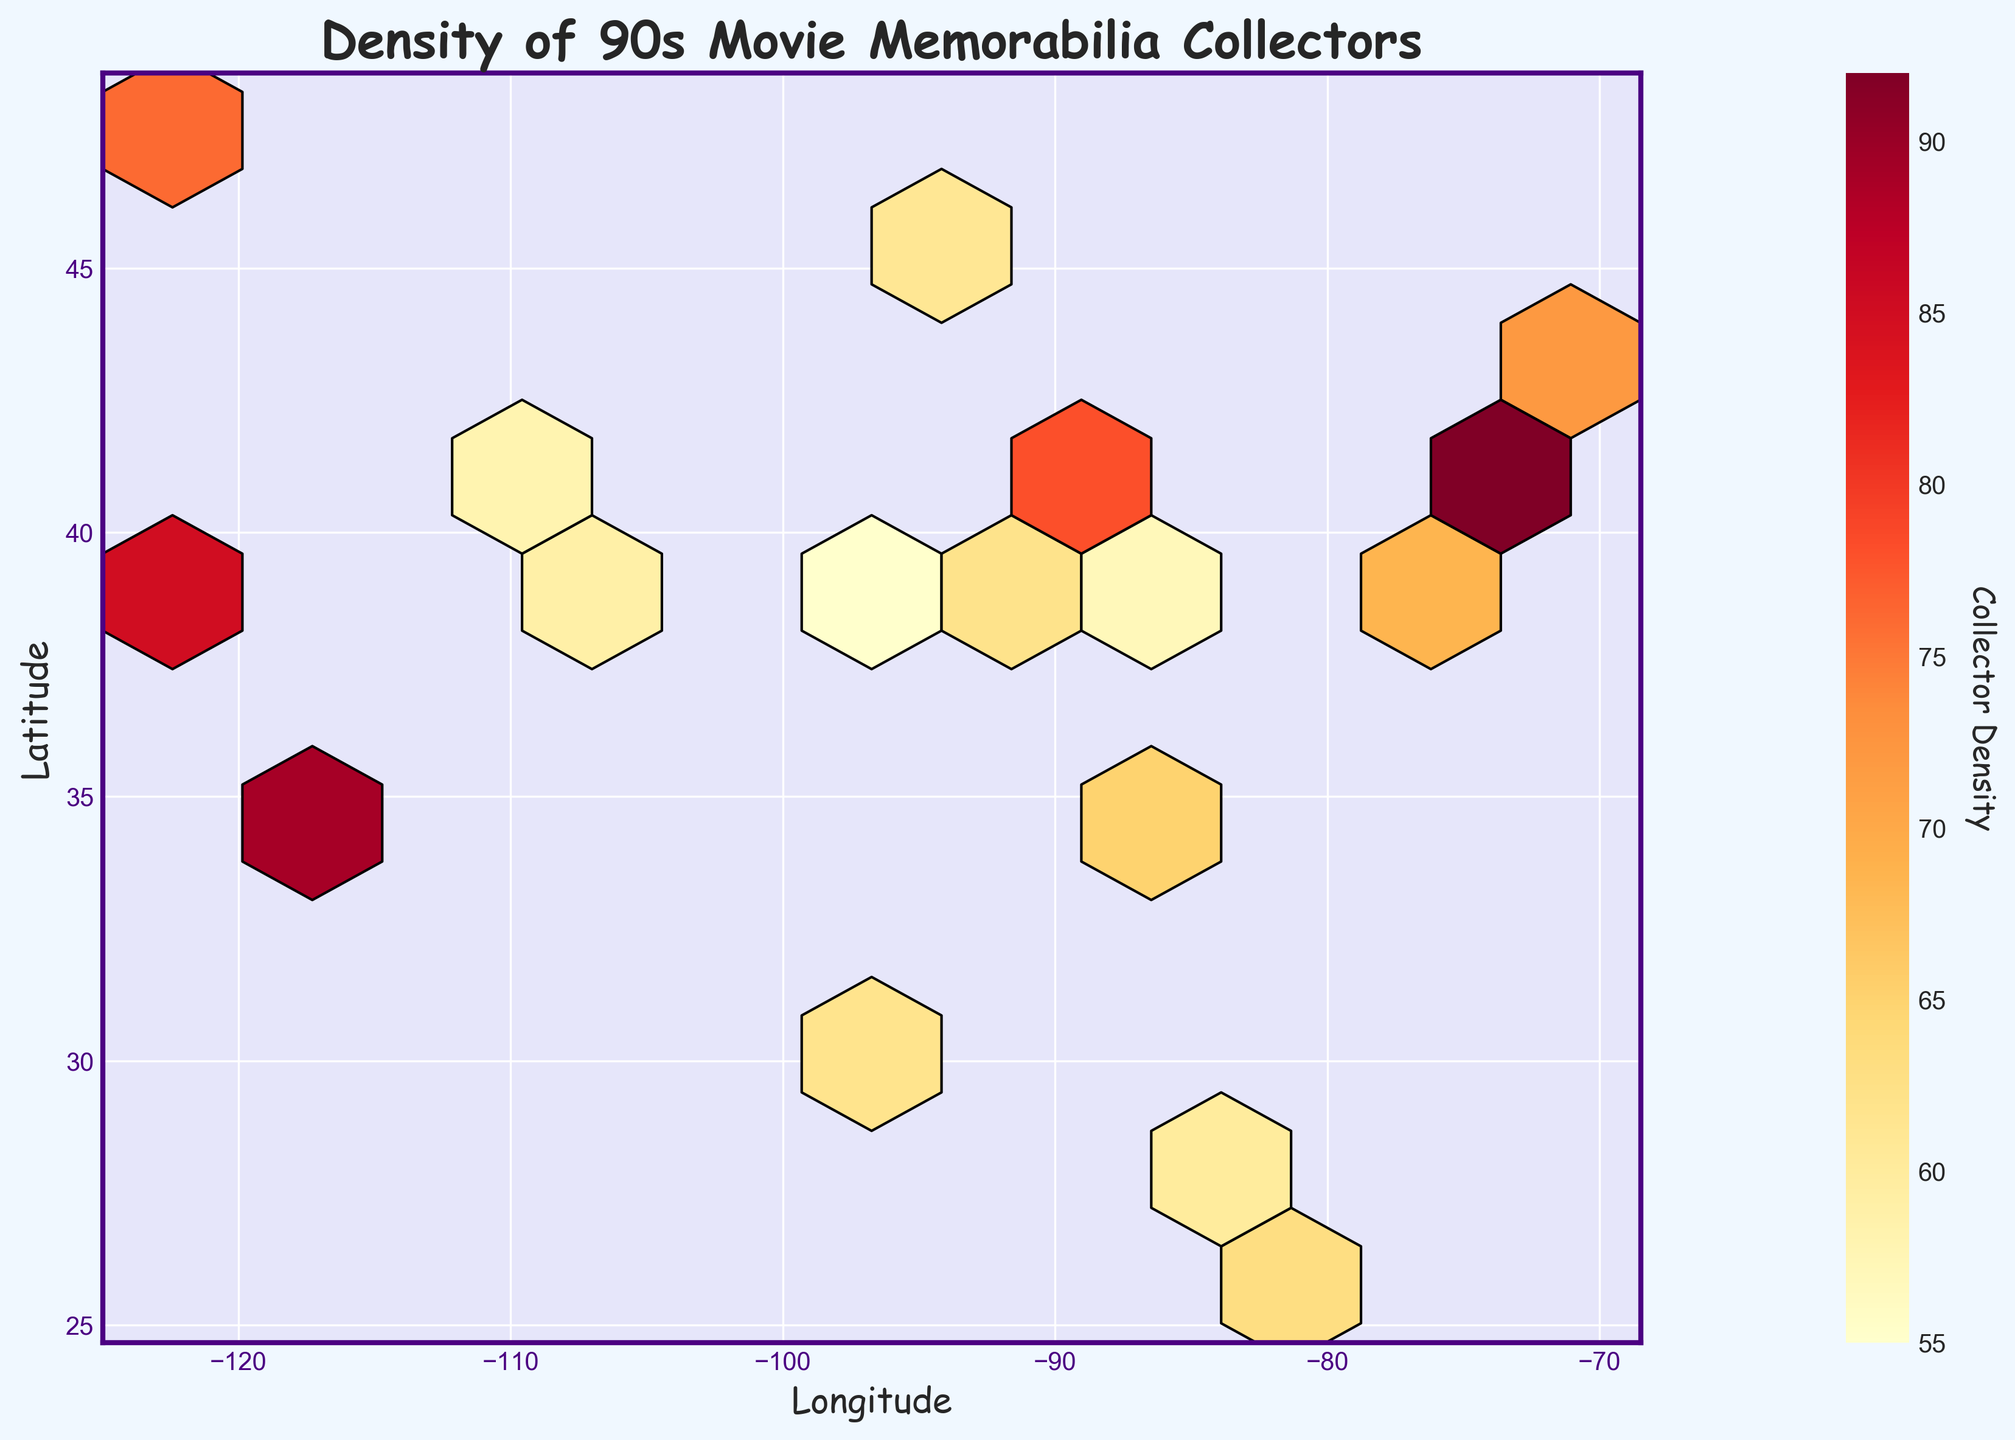what is the title of the figure? The title of the figure is typically located at the top of the plot. From the given data, it appears to be "Density of 90s Movie Memorabilia Collectors".
Answer: Density of 90s Movie Memorabilia Collectors What is the color scheme used in the plot? The color scheme used appears to be YlOrRd, which ranges from yellow to red, often used to indicate intensity or density with red indicating higher density and yellow indicating lower density.
Answer: Yellow to red Which region has the highest collector density? To find the region with the highest density, you should look for the darkest red hexagon on the plot, which corresponds to the highest collector density value. According to the data, the highest density is 92 in New York (longitude -74.0060, latitude 40.7128).
Answer: New York What are the ranges of the axes (Longitude and Latitude)? The axis ranges can be identified from the figure by looking at the minimum and maximum values shown on the x and y axes. Based on data, Longitude (x) ranges roughly from -122 to -74, and Latitude (y) ranges from 29 to 47.
Answer: Longitude: -122 to -74, Latitude: 29 to 47 Which cities have a collector density value between 60 and 70? By checking the 'density' column in the data, you can identify cities with collector densities between 60 and 70, such as Denver, Miami, Minneapolis, Orlando, and Washington DC.
Answer: Denver, Miami, Minneapolis, Orlando, Washington DC How does the collector density compare between Los Angeles and Houston? Comparing the density values for these cities, Los Angeles (89) has a higher density than Houston (68).
Answer: Los Angeles has higher density Which city has the lowest collector density and what is its value? The lowest value in the 'density' column can be found by comparing all the densities. San Antonio has the lowest density, which is 53.
Answer: San Antonio, 53 What is the median collector density value across all regions? To find the median, list all density values in numerical order and find the middle value or the average of the two middle values for an even number of data points. Sorting the values and finding the midpoint yields the median density.
Answer: 65.5 What is the average collector density across all regions? To compute the average, add all density values and then divide by the number of data points. Sum all values from the given density data (85, 92, 78, 89, 72, 65, 70, 68, 63, 76, 59, 61, 57, 64, 58, 62, 55, 53, 67, 60) and divide by 20. (1520/20 = 76).
Answer: 76 What background color is used for the figure and the plot area separately? The background color of the figure is Alice blue, and the plot area has a light lavender color background.
Answer: Alice blue, light lavender 